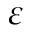Convert formula to latex. <formula><loc_0><loc_0><loc_500><loc_500>\varepsilon</formula> 